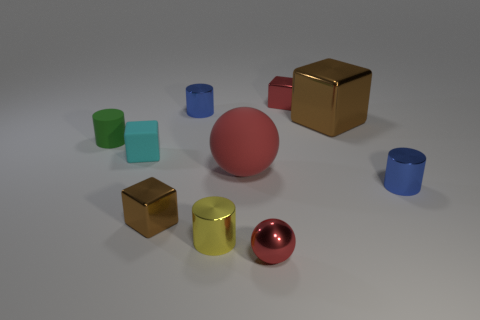What size is the metallic sphere that is the same color as the matte ball?
Ensure brevity in your answer.  Small. Is the number of red metallic cubes that are on the left side of the small brown metal cube the same as the number of matte balls?
Offer a terse response. No. How many shiny things are right of the yellow cylinder and in front of the large red object?
Your answer should be compact. 2. The red thing that is the same material as the cyan object is what size?
Provide a short and direct response. Large. How many other yellow things have the same shape as the small yellow object?
Offer a terse response. 0. Are there more tiny yellow cylinders that are on the left side of the red shiny cube than yellow objects?
Your answer should be very brief. No. The small object that is both on the right side of the small red ball and in front of the tiny cyan cube has what shape?
Your answer should be compact. Cylinder. Do the green matte cylinder and the red matte ball have the same size?
Offer a very short reply. No. There is a tiny red metallic block; what number of green matte objects are in front of it?
Your answer should be compact. 1. Are there the same number of cylinders that are right of the cyan matte block and small yellow metal objects to the left of the big cube?
Your answer should be very brief. No. 